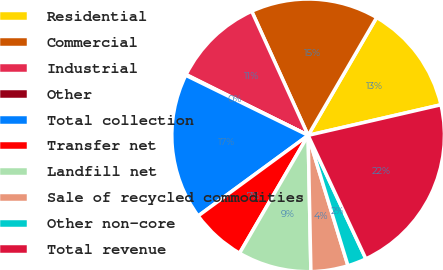Convert chart. <chart><loc_0><loc_0><loc_500><loc_500><pie_chart><fcel>Residential<fcel>Commercial<fcel>Industrial<fcel>Other<fcel>Total collection<fcel>Transfer net<fcel>Landfill net<fcel>Sale of recycled commodities<fcel>Other non-core<fcel>Total revenue<nl><fcel>13.02%<fcel>15.17%<fcel>10.86%<fcel>0.09%<fcel>17.33%<fcel>6.55%<fcel>8.71%<fcel>4.4%<fcel>2.24%<fcel>21.64%<nl></chart> 